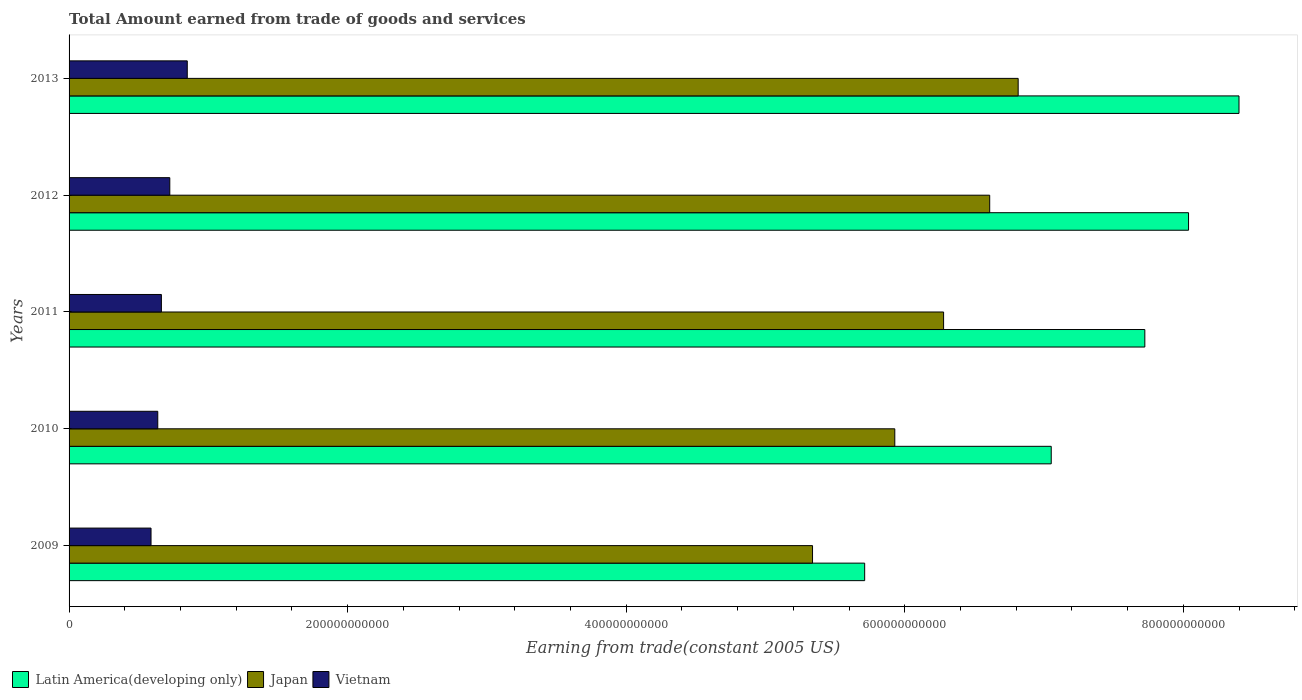How many different coloured bars are there?
Your response must be concise. 3. Are the number of bars per tick equal to the number of legend labels?
Your response must be concise. Yes. How many bars are there on the 3rd tick from the top?
Offer a terse response. 3. In how many cases, is the number of bars for a given year not equal to the number of legend labels?
Your answer should be very brief. 0. What is the total amount earned by trading goods and services in Latin America(developing only) in 2013?
Make the answer very short. 8.40e+11. Across all years, what is the maximum total amount earned by trading goods and services in Japan?
Make the answer very short. 6.81e+11. Across all years, what is the minimum total amount earned by trading goods and services in Latin America(developing only)?
Offer a very short reply. 5.71e+11. In which year was the total amount earned by trading goods and services in Latin America(developing only) maximum?
Your response must be concise. 2013. What is the total total amount earned by trading goods and services in Latin America(developing only) in the graph?
Give a very brief answer. 3.69e+12. What is the difference between the total amount earned by trading goods and services in Japan in 2009 and that in 2012?
Your response must be concise. -1.27e+11. What is the difference between the total amount earned by trading goods and services in Latin America(developing only) in 2009 and the total amount earned by trading goods and services in Vietnam in 2013?
Offer a very short reply. 4.86e+11. What is the average total amount earned by trading goods and services in Latin America(developing only) per year?
Provide a short and direct response. 7.38e+11. In the year 2012, what is the difference between the total amount earned by trading goods and services in Vietnam and total amount earned by trading goods and services in Japan?
Provide a succinct answer. -5.89e+11. What is the ratio of the total amount earned by trading goods and services in Latin America(developing only) in 2012 to that in 2013?
Your answer should be compact. 0.96. Is the difference between the total amount earned by trading goods and services in Vietnam in 2012 and 2013 greater than the difference between the total amount earned by trading goods and services in Japan in 2012 and 2013?
Make the answer very short. Yes. What is the difference between the highest and the second highest total amount earned by trading goods and services in Japan?
Ensure brevity in your answer.  2.04e+1. What is the difference between the highest and the lowest total amount earned by trading goods and services in Latin America(developing only)?
Make the answer very short. 2.69e+11. What does the 1st bar from the top in 2010 represents?
Make the answer very short. Vietnam. What does the 1st bar from the bottom in 2013 represents?
Offer a very short reply. Latin America(developing only). How many bars are there?
Offer a terse response. 15. Are all the bars in the graph horizontal?
Your answer should be very brief. Yes. How many years are there in the graph?
Provide a short and direct response. 5. What is the difference between two consecutive major ticks on the X-axis?
Your response must be concise. 2.00e+11. Are the values on the major ticks of X-axis written in scientific E-notation?
Give a very brief answer. No. How many legend labels are there?
Provide a short and direct response. 3. How are the legend labels stacked?
Give a very brief answer. Horizontal. What is the title of the graph?
Your answer should be very brief. Total Amount earned from trade of goods and services. What is the label or title of the X-axis?
Provide a succinct answer. Earning from trade(constant 2005 US). What is the label or title of the Y-axis?
Provide a succinct answer. Years. What is the Earning from trade(constant 2005 US) of Latin America(developing only) in 2009?
Make the answer very short. 5.71e+11. What is the Earning from trade(constant 2005 US) in Japan in 2009?
Your response must be concise. 5.34e+11. What is the Earning from trade(constant 2005 US) in Vietnam in 2009?
Make the answer very short. 5.88e+1. What is the Earning from trade(constant 2005 US) in Latin America(developing only) in 2010?
Offer a very short reply. 7.05e+11. What is the Earning from trade(constant 2005 US) in Japan in 2010?
Keep it short and to the point. 5.93e+11. What is the Earning from trade(constant 2005 US) in Vietnam in 2010?
Provide a succinct answer. 6.37e+1. What is the Earning from trade(constant 2005 US) of Latin America(developing only) in 2011?
Your answer should be very brief. 7.72e+11. What is the Earning from trade(constant 2005 US) in Japan in 2011?
Provide a short and direct response. 6.28e+11. What is the Earning from trade(constant 2005 US) of Vietnam in 2011?
Offer a terse response. 6.63e+1. What is the Earning from trade(constant 2005 US) of Latin America(developing only) in 2012?
Make the answer very short. 8.04e+11. What is the Earning from trade(constant 2005 US) of Japan in 2012?
Make the answer very short. 6.61e+11. What is the Earning from trade(constant 2005 US) of Vietnam in 2012?
Offer a terse response. 7.23e+1. What is the Earning from trade(constant 2005 US) in Latin America(developing only) in 2013?
Provide a short and direct response. 8.40e+11. What is the Earning from trade(constant 2005 US) in Japan in 2013?
Give a very brief answer. 6.81e+11. What is the Earning from trade(constant 2005 US) of Vietnam in 2013?
Give a very brief answer. 8.49e+1. Across all years, what is the maximum Earning from trade(constant 2005 US) of Latin America(developing only)?
Offer a terse response. 8.40e+11. Across all years, what is the maximum Earning from trade(constant 2005 US) in Japan?
Make the answer very short. 6.81e+11. Across all years, what is the maximum Earning from trade(constant 2005 US) in Vietnam?
Give a very brief answer. 8.49e+1. Across all years, what is the minimum Earning from trade(constant 2005 US) of Latin America(developing only)?
Provide a short and direct response. 5.71e+11. Across all years, what is the minimum Earning from trade(constant 2005 US) in Japan?
Ensure brevity in your answer.  5.34e+11. Across all years, what is the minimum Earning from trade(constant 2005 US) in Vietnam?
Your answer should be very brief. 5.88e+1. What is the total Earning from trade(constant 2005 US) in Latin America(developing only) in the graph?
Offer a terse response. 3.69e+12. What is the total Earning from trade(constant 2005 US) in Japan in the graph?
Your answer should be compact. 3.10e+12. What is the total Earning from trade(constant 2005 US) of Vietnam in the graph?
Ensure brevity in your answer.  3.46e+11. What is the difference between the Earning from trade(constant 2005 US) of Latin America(developing only) in 2009 and that in 2010?
Give a very brief answer. -1.34e+11. What is the difference between the Earning from trade(constant 2005 US) of Japan in 2009 and that in 2010?
Your answer should be very brief. -5.91e+1. What is the difference between the Earning from trade(constant 2005 US) in Vietnam in 2009 and that in 2010?
Make the answer very short. -4.84e+09. What is the difference between the Earning from trade(constant 2005 US) in Latin America(developing only) in 2009 and that in 2011?
Your answer should be very brief. -2.01e+11. What is the difference between the Earning from trade(constant 2005 US) of Japan in 2009 and that in 2011?
Your answer should be very brief. -9.41e+1. What is the difference between the Earning from trade(constant 2005 US) in Vietnam in 2009 and that in 2011?
Provide a succinct answer. -7.45e+09. What is the difference between the Earning from trade(constant 2005 US) in Latin America(developing only) in 2009 and that in 2012?
Keep it short and to the point. -2.33e+11. What is the difference between the Earning from trade(constant 2005 US) of Japan in 2009 and that in 2012?
Make the answer very short. -1.27e+11. What is the difference between the Earning from trade(constant 2005 US) in Vietnam in 2009 and that in 2012?
Offer a very short reply. -1.35e+1. What is the difference between the Earning from trade(constant 2005 US) in Latin America(developing only) in 2009 and that in 2013?
Offer a terse response. -2.69e+11. What is the difference between the Earning from trade(constant 2005 US) in Japan in 2009 and that in 2013?
Give a very brief answer. -1.48e+11. What is the difference between the Earning from trade(constant 2005 US) of Vietnam in 2009 and that in 2013?
Offer a very short reply. -2.60e+1. What is the difference between the Earning from trade(constant 2005 US) in Latin America(developing only) in 2010 and that in 2011?
Your response must be concise. -6.72e+1. What is the difference between the Earning from trade(constant 2005 US) in Japan in 2010 and that in 2011?
Your answer should be very brief. -3.50e+1. What is the difference between the Earning from trade(constant 2005 US) in Vietnam in 2010 and that in 2011?
Your response must be concise. -2.61e+09. What is the difference between the Earning from trade(constant 2005 US) of Latin America(developing only) in 2010 and that in 2012?
Ensure brevity in your answer.  -9.86e+1. What is the difference between the Earning from trade(constant 2005 US) in Japan in 2010 and that in 2012?
Keep it short and to the point. -6.81e+1. What is the difference between the Earning from trade(constant 2005 US) of Vietnam in 2010 and that in 2012?
Offer a terse response. -8.64e+09. What is the difference between the Earning from trade(constant 2005 US) of Latin America(developing only) in 2010 and that in 2013?
Your answer should be very brief. -1.35e+11. What is the difference between the Earning from trade(constant 2005 US) in Japan in 2010 and that in 2013?
Your answer should be very brief. -8.86e+1. What is the difference between the Earning from trade(constant 2005 US) in Vietnam in 2010 and that in 2013?
Your answer should be very brief. -2.12e+1. What is the difference between the Earning from trade(constant 2005 US) of Latin America(developing only) in 2011 and that in 2012?
Make the answer very short. -3.14e+1. What is the difference between the Earning from trade(constant 2005 US) in Japan in 2011 and that in 2012?
Offer a very short reply. -3.31e+1. What is the difference between the Earning from trade(constant 2005 US) of Vietnam in 2011 and that in 2012?
Make the answer very short. -6.03e+09. What is the difference between the Earning from trade(constant 2005 US) in Latin America(developing only) in 2011 and that in 2013?
Offer a terse response. -6.76e+1. What is the difference between the Earning from trade(constant 2005 US) of Japan in 2011 and that in 2013?
Provide a succinct answer. -5.35e+1. What is the difference between the Earning from trade(constant 2005 US) in Vietnam in 2011 and that in 2013?
Your response must be concise. -1.86e+1. What is the difference between the Earning from trade(constant 2005 US) in Latin America(developing only) in 2012 and that in 2013?
Give a very brief answer. -3.62e+1. What is the difference between the Earning from trade(constant 2005 US) of Japan in 2012 and that in 2013?
Provide a succinct answer. -2.04e+1. What is the difference between the Earning from trade(constant 2005 US) in Vietnam in 2012 and that in 2013?
Give a very brief answer. -1.25e+1. What is the difference between the Earning from trade(constant 2005 US) in Latin America(developing only) in 2009 and the Earning from trade(constant 2005 US) in Japan in 2010?
Your response must be concise. -2.16e+1. What is the difference between the Earning from trade(constant 2005 US) of Latin America(developing only) in 2009 and the Earning from trade(constant 2005 US) of Vietnam in 2010?
Offer a terse response. 5.08e+11. What is the difference between the Earning from trade(constant 2005 US) of Japan in 2009 and the Earning from trade(constant 2005 US) of Vietnam in 2010?
Give a very brief answer. 4.70e+11. What is the difference between the Earning from trade(constant 2005 US) in Latin America(developing only) in 2009 and the Earning from trade(constant 2005 US) in Japan in 2011?
Your answer should be very brief. -5.67e+1. What is the difference between the Earning from trade(constant 2005 US) in Latin America(developing only) in 2009 and the Earning from trade(constant 2005 US) in Vietnam in 2011?
Your answer should be very brief. 5.05e+11. What is the difference between the Earning from trade(constant 2005 US) in Japan in 2009 and the Earning from trade(constant 2005 US) in Vietnam in 2011?
Provide a succinct answer. 4.67e+11. What is the difference between the Earning from trade(constant 2005 US) in Latin America(developing only) in 2009 and the Earning from trade(constant 2005 US) in Japan in 2012?
Your answer should be compact. -8.98e+1. What is the difference between the Earning from trade(constant 2005 US) of Latin America(developing only) in 2009 and the Earning from trade(constant 2005 US) of Vietnam in 2012?
Keep it short and to the point. 4.99e+11. What is the difference between the Earning from trade(constant 2005 US) of Japan in 2009 and the Earning from trade(constant 2005 US) of Vietnam in 2012?
Your answer should be very brief. 4.61e+11. What is the difference between the Earning from trade(constant 2005 US) in Latin America(developing only) in 2009 and the Earning from trade(constant 2005 US) in Japan in 2013?
Your response must be concise. -1.10e+11. What is the difference between the Earning from trade(constant 2005 US) in Latin America(developing only) in 2009 and the Earning from trade(constant 2005 US) in Vietnam in 2013?
Keep it short and to the point. 4.86e+11. What is the difference between the Earning from trade(constant 2005 US) of Japan in 2009 and the Earning from trade(constant 2005 US) of Vietnam in 2013?
Ensure brevity in your answer.  4.49e+11. What is the difference between the Earning from trade(constant 2005 US) in Latin America(developing only) in 2010 and the Earning from trade(constant 2005 US) in Japan in 2011?
Your answer should be compact. 7.73e+1. What is the difference between the Earning from trade(constant 2005 US) of Latin America(developing only) in 2010 and the Earning from trade(constant 2005 US) of Vietnam in 2011?
Provide a succinct answer. 6.39e+11. What is the difference between the Earning from trade(constant 2005 US) of Japan in 2010 and the Earning from trade(constant 2005 US) of Vietnam in 2011?
Provide a succinct answer. 5.27e+11. What is the difference between the Earning from trade(constant 2005 US) of Latin America(developing only) in 2010 and the Earning from trade(constant 2005 US) of Japan in 2012?
Your answer should be compact. 4.42e+1. What is the difference between the Earning from trade(constant 2005 US) of Latin America(developing only) in 2010 and the Earning from trade(constant 2005 US) of Vietnam in 2012?
Give a very brief answer. 6.33e+11. What is the difference between the Earning from trade(constant 2005 US) in Japan in 2010 and the Earning from trade(constant 2005 US) in Vietnam in 2012?
Offer a very short reply. 5.20e+11. What is the difference between the Earning from trade(constant 2005 US) of Latin America(developing only) in 2010 and the Earning from trade(constant 2005 US) of Japan in 2013?
Offer a terse response. 2.37e+1. What is the difference between the Earning from trade(constant 2005 US) in Latin America(developing only) in 2010 and the Earning from trade(constant 2005 US) in Vietnam in 2013?
Make the answer very short. 6.20e+11. What is the difference between the Earning from trade(constant 2005 US) of Japan in 2010 and the Earning from trade(constant 2005 US) of Vietnam in 2013?
Offer a very short reply. 5.08e+11. What is the difference between the Earning from trade(constant 2005 US) of Latin America(developing only) in 2011 and the Earning from trade(constant 2005 US) of Japan in 2012?
Provide a succinct answer. 1.11e+11. What is the difference between the Earning from trade(constant 2005 US) of Latin America(developing only) in 2011 and the Earning from trade(constant 2005 US) of Vietnam in 2012?
Your response must be concise. 7.00e+11. What is the difference between the Earning from trade(constant 2005 US) of Japan in 2011 and the Earning from trade(constant 2005 US) of Vietnam in 2012?
Offer a terse response. 5.56e+11. What is the difference between the Earning from trade(constant 2005 US) of Latin America(developing only) in 2011 and the Earning from trade(constant 2005 US) of Japan in 2013?
Offer a very short reply. 9.09e+1. What is the difference between the Earning from trade(constant 2005 US) in Latin America(developing only) in 2011 and the Earning from trade(constant 2005 US) in Vietnam in 2013?
Provide a short and direct response. 6.87e+11. What is the difference between the Earning from trade(constant 2005 US) of Japan in 2011 and the Earning from trade(constant 2005 US) of Vietnam in 2013?
Offer a terse response. 5.43e+11. What is the difference between the Earning from trade(constant 2005 US) in Latin America(developing only) in 2012 and the Earning from trade(constant 2005 US) in Japan in 2013?
Ensure brevity in your answer.  1.22e+11. What is the difference between the Earning from trade(constant 2005 US) of Latin America(developing only) in 2012 and the Earning from trade(constant 2005 US) of Vietnam in 2013?
Make the answer very short. 7.19e+11. What is the difference between the Earning from trade(constant 2005 US) of Japan in 2012 and the Earning from trade(constant 2005 US) of Vietnam in 2013?
Provide a short and direct response. 5.76e+11. What is the average Earning from trade(constant 2005 US) of Latin America(developing only) per year?
Offer a very short reply. 7.38e+11. What is the average Earning from trade(constant 2005 US) of Japan per year?
Your answer should be very brief. 6.19e+11. What is the average Earning from trade(constant 2005 US) in Vietnam per year?
Your response must be concise. 6.92e+1. In the year 2009, what is the difference between the Earning from trade(constant 2005 US) of Latin America(developing only) and Earning from trade(constant 2005 US) of Japan?
Make the answer very short. 3.74e+1. In the year 2009, what is the difference between the Earning from trade(constant 2005 US) in Latin America(developing only) and Earning from trade(constant 2005 US) in Vietnam?
Give a very brief answer. 5.12e+11. In the year 2009, what is the difference between the Earning from trade(constant 2005 US) of Japan and Earning from trade(constant 2005 US) of Vietnam?
Ensure brevity in your answer.  4.75e+11. In the year 2010, what is the difference between the Earning from trade(constant 2005 US) in Latin America(developing only) and Earning from trade(constant 2005 US) in Japan?
Provide a succinct answer. 1.12e+11. In the year 2010, what is the difference between the Earning from trade(constant 2005 US) in Latin America(developing only) and Earning from trade(constant 2005 US) in Vietnam?
Offer a terse response. 6.41e+11. In the year 2010, what is the difference between the Earning from trade(constant 2005 US) of Japan and Earning from trade(constant 2005 US) of Vietnam?
Provide a short and direct response. 5.29e+11. In the year 2011, what is the difference between the Earning from trade(constant 2005 US) of Latin America(developing only) and Earning from trade(constant 2005 US) of Japan?
Give a very brief answer. 1.44e+11. In the year 2011, what is the difference between the Earning from trade(constant 2005 US) of Latin America(developing only) and Earning from trade(constant 2005 US) of Vietnam?
Provide a short and direct response. 7.06e+11. In the year 2011, what is the difference between the Earning from trade(constant 2005 US) of Japan and Earning from trade(constant 2005 US) of Vietnam?
Provide a short and direct response. 5.62e+11. In the year 2012, what is the difference between the Earning from trade(constant 2005 US) in Latin America(developing only) and Earning from trade(constant 2005 US) in Japan?
Your answer should be very brief. 1.43e+11. In the year 2012, what is the difference between the Earning from trade(constant 2005 US) of Latin America(developing only) and Earning from trade(constant 2005 US) of Vietnam?
Offer a terse response. 7.31e+11. In the year 2012, what is the difference between the Earning from trade(constant 2005 US) in Japan and Earning from trade(constant 2005 US) in Vietnam?
Your response must be concise. 5.89e+11. In the year 2013, what is the difference between the Earning from trade(constant 2005 US) in Latin America(developing only) and Earning from trade(constant 2005 US) in Japan?
Make the answer very short. 1.59e+11. In the year 2013, what is the difference between the Earning from trade(constant 2005 US) of Latin America(developing only) and Earning from trade(constant 2005 US) of Vietnam?
Offer a very short reply. 7.55e+11. In the year 2013, what is the difference between the Earning from trade(constant 2005 US) in Japan and Earning from trade(constant 2005 US) in Vietnam?
Give a very brief answer. 5.97e+11. What is the ratio of the Earning from trade(constant 2005 US) in Latin America(developing only) in 2009 to that in 2010?
Offer a very short reply. 0.81. What is the ratio of the Earning from trade(constant 2005 US) of Japan in 2009 to that in 2010?
Provide a succinct answer. 0.9. What is the ratio of the Earning from trade(constant 2005 US) of Vietnam in 2009 to that in 2010?
Keep it short and to the point. 0.92. What is the ratio of the Earning from trade(constant 2005 US) of Latin America(developing only) in 2009 to that in 2011?
Your response must be concise. 0.74. What is the ratio of the Earning from trade(constant 2005 US) in Japan in 2009 to that in 2011?
Offer a terse response. 0.85. What is the ratio of the Earning from trade(constant 2005 US) in Vietnam in 2009 to that in 2011?
Your response must be concise. 0.89. What is the ratio of the Earning from trade(constant 2005 US) in Latin America(developing only) in 2009 to that in 2012?
Ensure brevity in your answer.  0.71. What is the ratio of the Earning from trade(constant 2005 US) in Japan in 2009 to that in 2012?
Ensure brevity in your answer.  0.81. What is the ratio of the Earning from trade(constant 2005 US) of Vietnam in 2009 to that in 2012?
Ensure brevity in your answer.  0.81. What is the ratio of the Earning from trade(constant 2005 US) in Latin America(developing only) in 2009 to that in 2013?
Your answer should be very brief. 0.68. What is the ratio of the Earning from trade(constant 2005 US) of Japan in 2009 to that in 2013?
Provide a succinct answer. 0.78. What is the ratio of the Earning from trade(constant 2005 US) in Vietnam in 2009 to that in 2013?
Keep it short and to the point. 0.69. What is the ratio of the Earning from trade(constant 2005 US) of Latin America(developing only) in 2010 to that in 2011?
Make the answer very short. 0.91. What is the ratio of the Earning from trade(constant 2005 US) in Japan in 2010 to that in 2011?
Give a very brief answer. 0.94. What is the ratio of the Earning from trade(constant 2005 US) of Vietnam in 2010 to that in 2011?
Give a very brief answer. 0.96. What is the ratio of the Earning from trade(constant 2005 US) in Latin America(developing only) in 2010 to that in 2012?
Your answer should be compact. 0.88. What is the ratio of the Earning from trade(constant 2005 US) of Japan in 2010 to that in 2012?
Your answer should be very brief. 0.9. What is the ratio of the Earning from trade(constant 2005 US) in Vietnam in 2010 to that in 2012?
Keep it short and to the point. 0.88. What is the ratio of the Earning from trade(constant 2005 US) in Latin America(developing only) in 2010 to that in 2013?
Your response must be concise. 0.84. What is the ratio of the Earning from trade(constant 2005 US) of Japan in 2010 to that in 2013?
Your answer should be compact. 0.87. What is the ratio of the Earning from trade(constant 2005 US) of Vietnam in 2010 to that in 2013?
Offer a very short reply. 0.75. What is the ratio of the Earning from trade(constant 2005 US) in Latin America(developing only) in 2011 to that in 2012?
Your answer should be very brief. 0.96. What is the ratio of the Earning from trade(constant 2005 US) in Japan in 2011 to that in 2012?
Provide a succinct answer. 0.95. What is the ratio of the Earning from trade(constant 2005 US) of Vietnam in 2011 to that in 2012?
Keep it short and to the point. 0.92. What is the ratio of the Earning from trade(constant 2005 US) in Latin America(developing only) in 2011 to that in 2013?
Your answer should be very brief. 0.92. What is the ratio of the Earning from trade(constant 2005 US) in Japan in 2011 to that in 2013?
Provide a succinct answer. 0.92. What is the ratio of the Earning from trade(constant 2005 US) in Vietnam in 2011 to that in 2013?
Provide a short and direct response. 0.78. What is the ratio of the Earning from trade(constant 2005 US) in Latin America(developing only) in 2012 to that in 2013?
Provide a short and direct response. 0.96. What is the ratio of the Earning from trade(constant 2005 US) in Japan in 2012 to that in 2013?
Offer a terse response. 0.97. What is the ratio of the Earning from trade(constant 2005 US) in Vietnam in 2012 to that in 2013?
Offer a terse response. 0.85. What is the difference between the highest and the second highest Earning from trade(constant 2005 US) of Latin America(developing only)?
Provide a succinct answer. 3.62e+1. What is the difference between the highest and the second highest Earning from trade(constant 2005 US) in Japan?
Give a very brief answer. 2.04e+1. What is the difference between the highest and the second highest Earning from trade(constant 2005 US) of Vietnam?
Keep it short and to the point. 1.25e+1. What is the difference between the highest and the lowest Earning from trade(constant 2005 US) in Latin America(developing only)?
Your answer should be compact. 2.69e+11. What is the difference between the highest and the lowest Earning from trade(constant 2005 US) in Japan?
Offer a terse response. 1.48e+11. What is the difference between the highest and the lowest Earning from trade(constant 2005 US) of Vietnam?
Make the answer very short. 2.60e+1. 